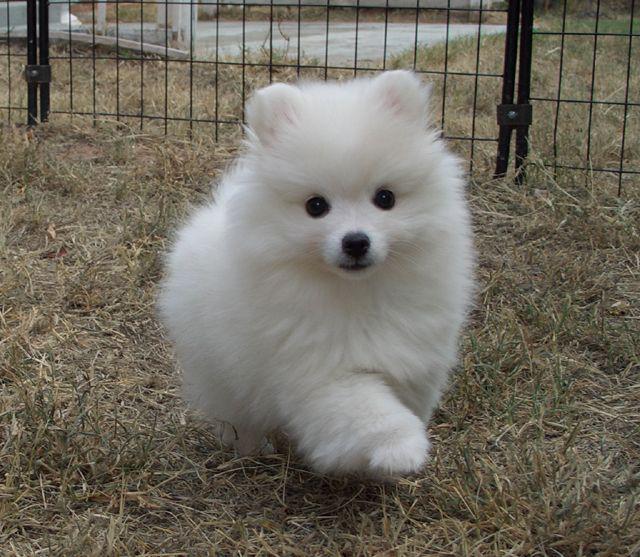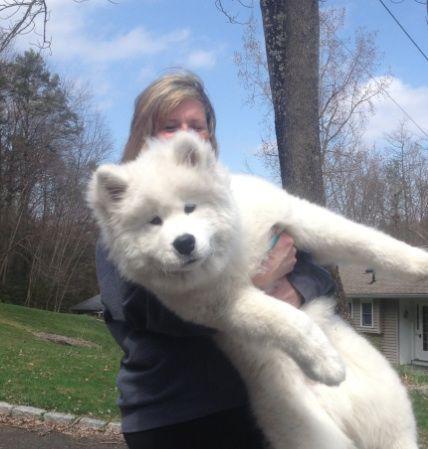The first image is the image on the left, the second image is the image on the right. Evaluate the accuracy of this statement regarding the images: "A person is visible behind three white dogs in one image.". Is it true? Answer yes or no. No. The first image is the image on the left, the second image is the image on the right. Examine the images to the left and right. Is the description "In one image, three white dogs are with a person." accurate? Answer yes or no. No. 